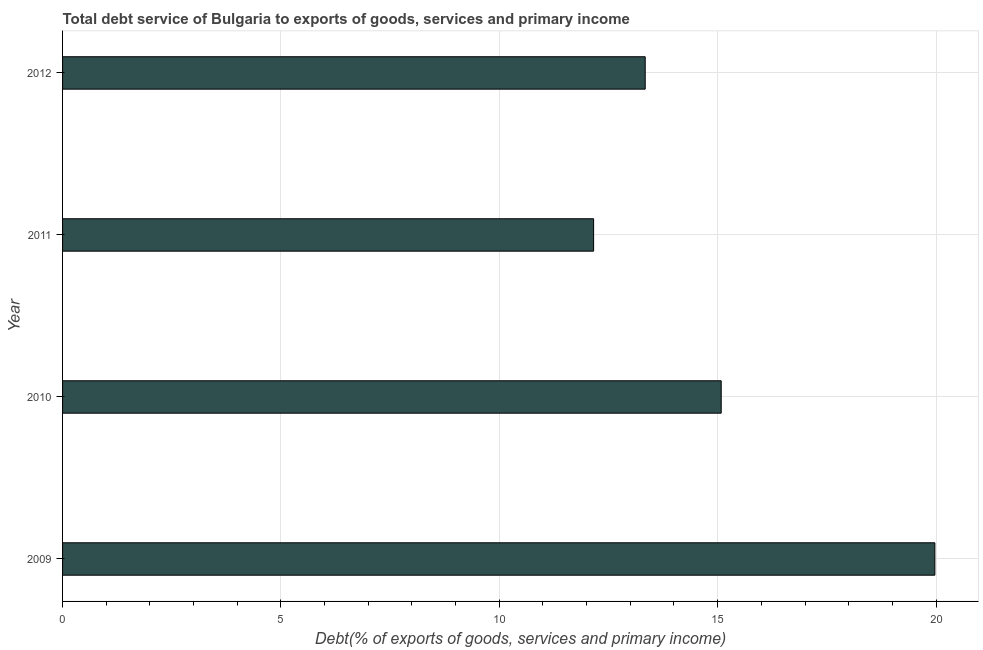What is the title of the graph?
Keep it short and to the point. Total debt service of Bulgaria to exports of goods, services and primary income. What is the label or title of the X-axis?
Keep it short and to the point. Debt(% of exports of goods, services and primary income). What is the label or title of the Y-axis?
Provide a succinct answer. Year. What is the total debt service in 2011?
Your response must be concise. 12.16. Across all years, what is the maximum total debt service?
Offer a very short reply. 19.97. Across all years, what is the minimum total debt service?
Offer a terse response. 12.16. In which year was the total debt service minimum?
Your answer should be very brief. 2011. What is the sum of the total debt service?
Make the answer very short. 60.56. What is the difference between the total debt service in 2009 and 2012?
Provide a succinct answer. 6.63. What is the average total debt service per year?
Your answer should be compact. 15.14. What is the median total debt service?
Offer a very short reply. 14.21. In how many years, is the total debt service greater than 2 %?
Ensure brevity in your answer.  4. What is the ratio of the total debt service in 2009 to that in 2010?
Ensure brevity in your answer.  1.32. Is the total debt service in 2009 less than that in 2010?
Give a very brief answer. No. Is the difference between the total debt service in 2010 and 2011 greater than the difference between any two years?
Make the answer very short. No. What is the difference between the highest and the second highest total debt service?
Provide a succinct answer. 4.89. Is the sum of the total debt service in 2010 and 2012 greater than the maximum total debt service across all years?
Make the answer very short. Yes. What is the difference between the highest and the lowest total debt service?
Offer a very short reply. 7.81. In how many years, is the total debt service greater than the average total debt service taken over all years?
Ensure brevity in your answer.  1. What is the Debt(% of exports of goods, services and primary income) in 2009?
Provide a short and direct response. 19.97. What is the Debt(% of exports of goods, services and primary income) of 2010?
Make the answer very short. 15.08. What is the Debt(% of exports of goods, services and primary income) in 2011?
Provide a succinct answer. 12.16. What is the Debt(% of exports of goods, services and primary income) in 2012?
Keep it short and to the point. 13.34. What is the difference between the Debt(% of exports of goods, services and primary income) in 2009 and 2010?
Your answer should be compact. 4.89. What is the difference between the Debt(% of exports of goods, services and primary income) in 2009 and 2011?
Your answer should be compact. 7.81. What is the difference between the Debt(% of exports of goods, services and primary income) in 2009 and 2012?
Provide a short and direct response. 6.63. What is the difference between the Debt(% of exports of goods, services and primary income) in 2010 and 2011?
Ensure brevity in your answer.  2.92. What is the difference between the Debt(% of exports of goods, services and primary income) in 2010 and 2012?
Offer a very short reply. 1.74. What is the difference between the Debt(% of exports of goods, services and primary income) in 2011 and 2012?
Ensure brevity in your answer.  -1.18. What is the ratio of the Debt(% of exports of goods, services and primary income) in 2009 to that in 2010?
Ensure brevity in your answer.  1.32. What is the ratio of the Debt(% of exports of goods, services and primary income) in 2009 to that in 2011?
Offer a very short reply. 1.64. What is the ratio of the Debt(% of exports of goods, services and primary income) in 2009 to that in 2012?
Provide a succinct answer. 1.5. What is the ratio of the Debt(% of exports of goods, services and primary income) in 2010 to that in 2011?
Offer a very short reply. 1.24. What is the ratio of the Debt(% of exports of goods, services and primary income) in 2010 to that in 2012?
Offer a very short reply. 1.13. What is the ratio of the Debt(% of exports of goods, services and primary income) in 2011 to that in 2012?
Give a very brief answer. 0.91. 